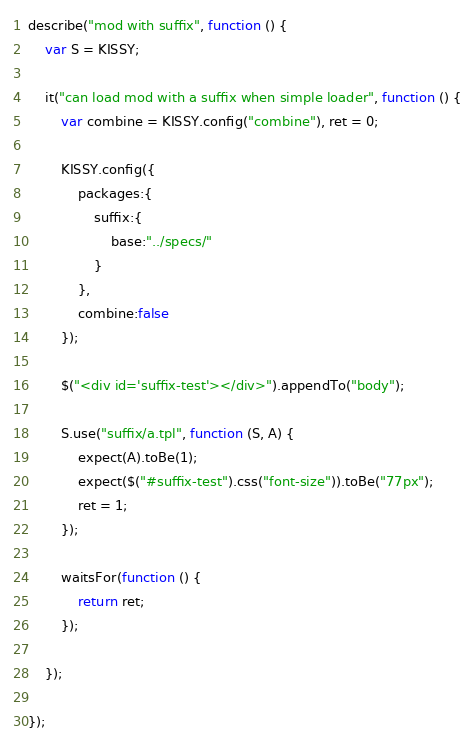<code> <loc_0><loc_0><loc_500><loc_500><_JavaScript_>describe("mod with suffix", function () {
    var S = KISSY;

    it("can load mod with a suffix when simple loader", function () {
        var combine = KISSY.config("combine"), ret = 0;

        KISSY.config({
            packages:{
                suffix:{
                    base:"../specs/"
                }
            },
            combine:false
        });

        $("<div id='suffix-test'></div>").appendTo("body");

        S.use("suffix/a.tpl", function (S, A) {
            expect(A).toBe(1);
            expect($("#suffix-test").css("font-size")).toBe("77px");
            ret = 1;
        });

        waitsFor(function () {
            return ret;
        });

    });

});</code> 